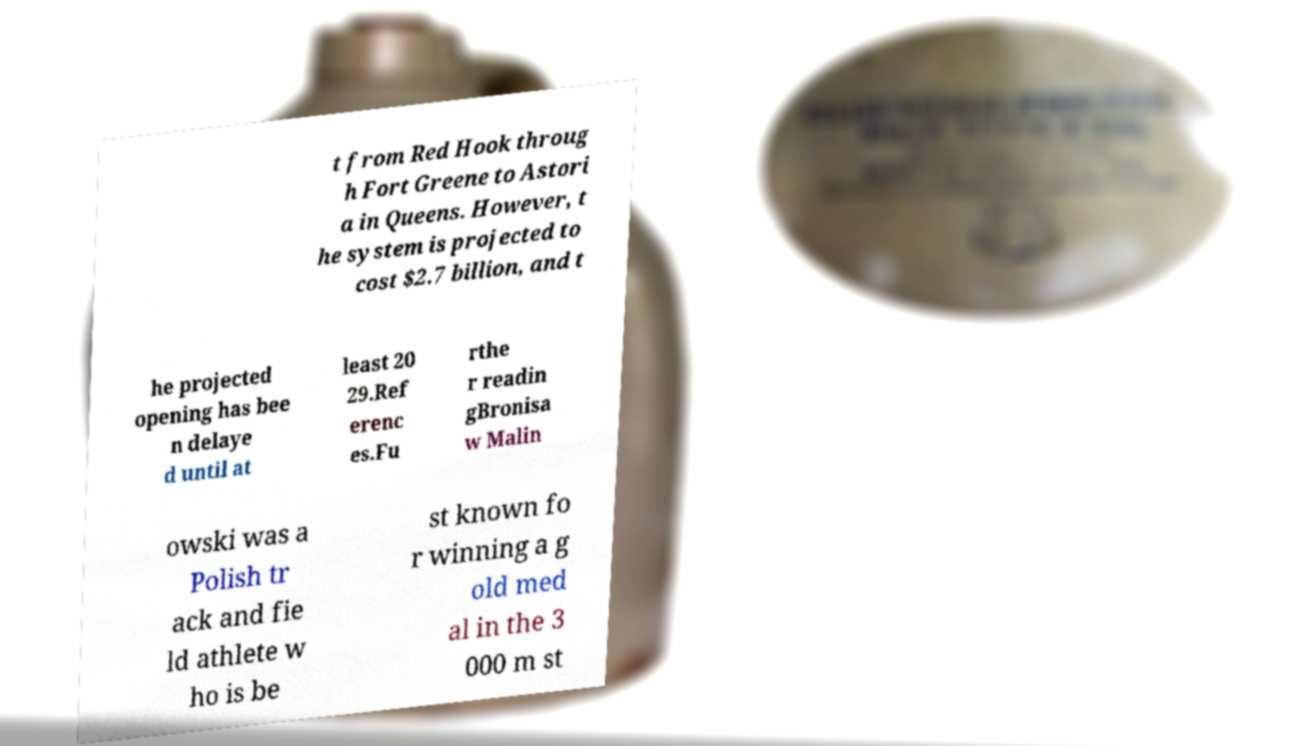Please identify and transcribe the text found in this image. t from Red Hook throug h Fort Greene to Astori a in Queens. However, t he system is projected to cost $2.7 billion, and t he projected opening has bee n delaye d until at least 20 29.Ref erenc es.Fu rthe r readin gBronisa w Malin owski was a Polish tr ack and fie ld athlete w ho is be st known fo r winning a g old med al in the 3 000 m st 